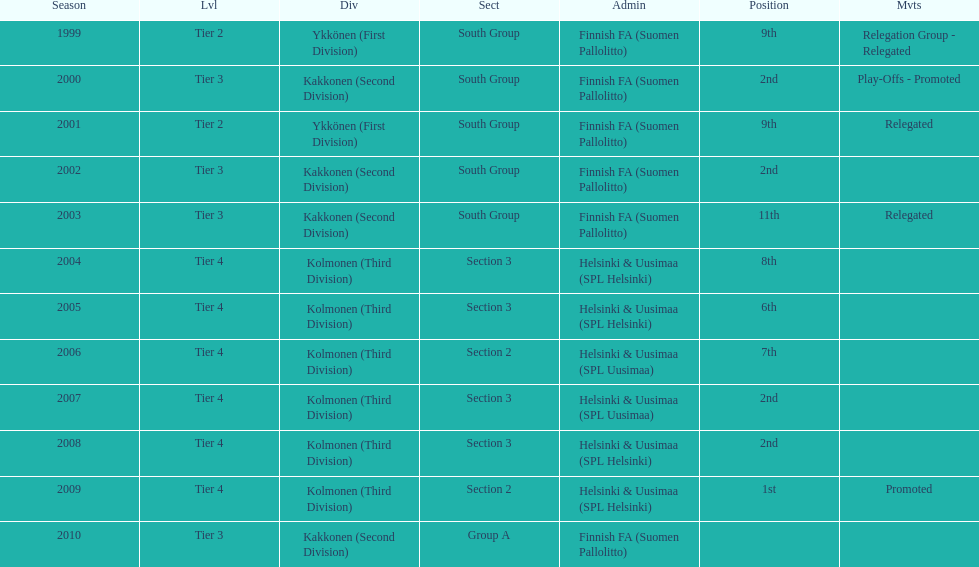What is the first tier listed? Tier 2. 